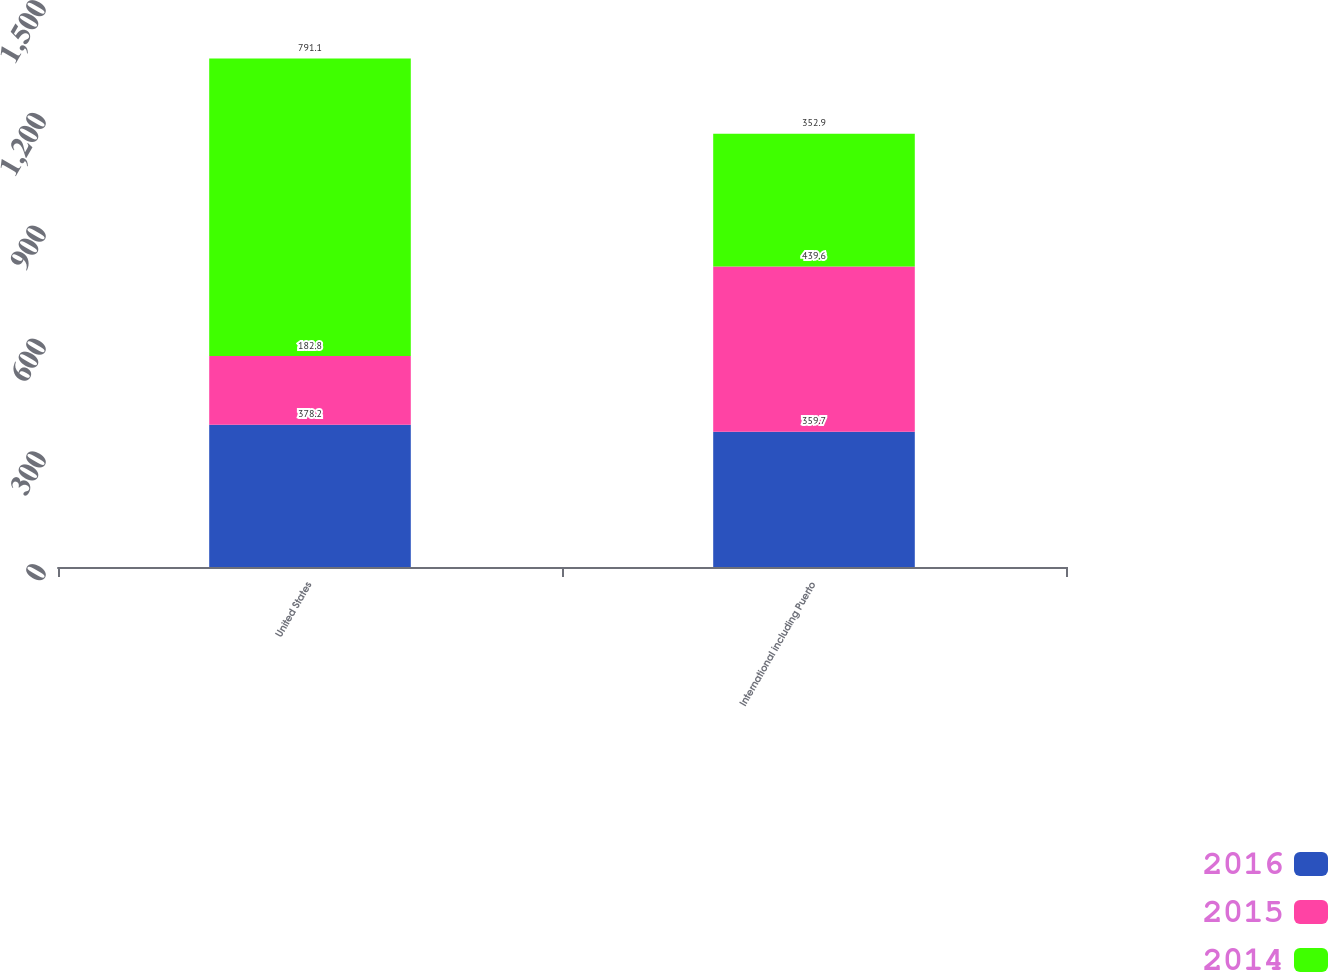Convert chart. <chart><loc_0><loc_0><loc_500><loc_500><stacked_bar_chart><ecel><fcel>United States<fcel>International including Puerto<nl><fcel>2016<fcel>378.2<fcel>359.7<nl><fcel>2015<fcel>182.8<fcel>439.6<nl><fcel>2014<fcel>791.1<fcel>352.9<nl></chart> 